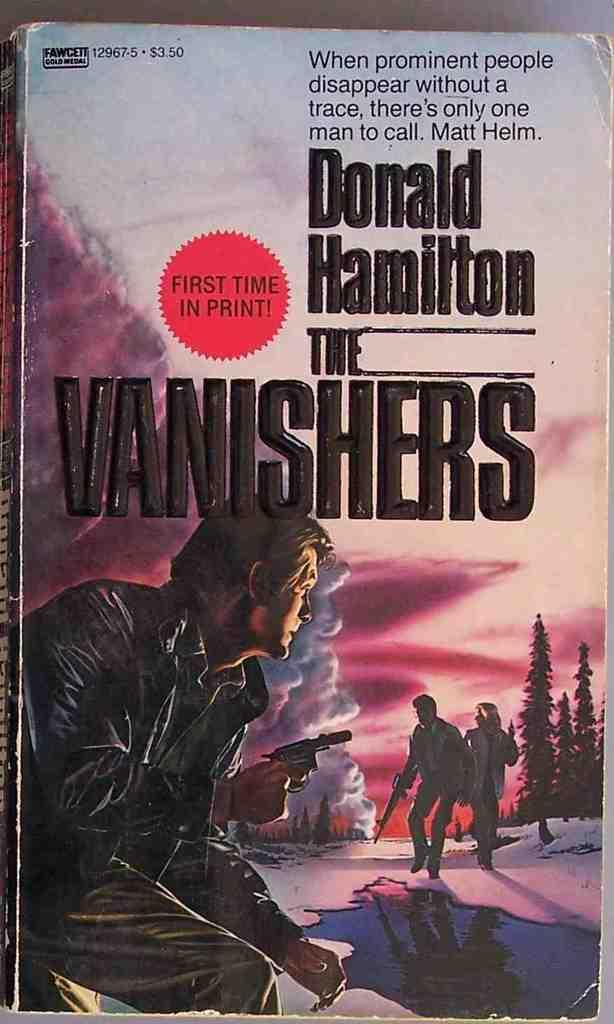<image>
Summarize the visual content of the image. A book by Donald Hamilton titled the vanishers 